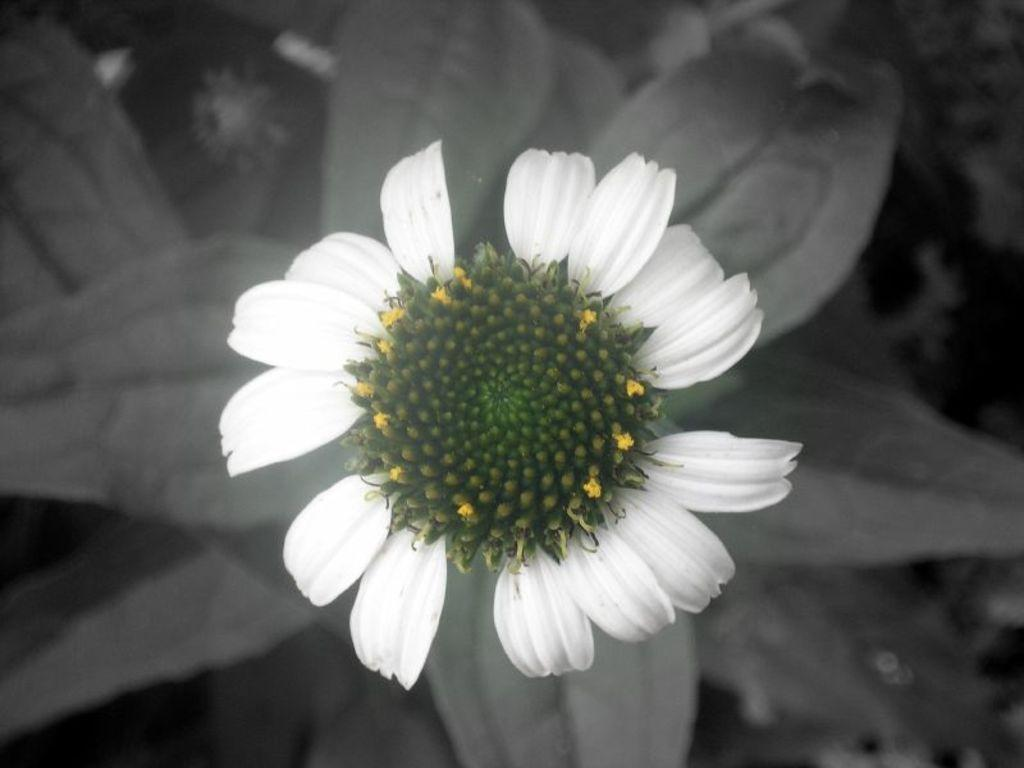What type of flower is present in the image? There is a white flower in the image. Are there any other parts of the plant visible in the image? Yes, there are green buds in the image. What day of the week is depicted in the image? The image does not depict a day of the week; it features a white flower and green buds. 